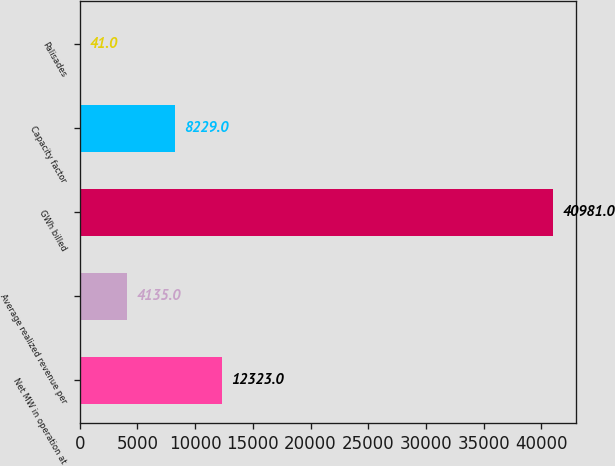<chart> <loc_0><loc_0><loc_500><loc_500><bar_chart><fcel>Net MW in operation at<fcel>Average realized revenue per<fcel>GWh billed<fcel>Capacity factor<fcel>Palisades<nl><fcel>12323<fcel>4135<fcel>40981<fcel>8229<fcel>41<nl></chart> 